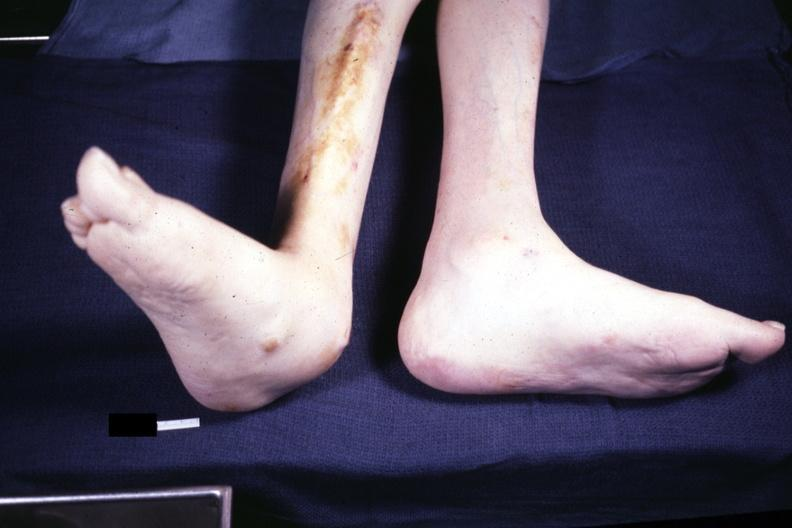what does this image show?
Answer the question using a single word or phrase. Typical deformity with lateral deviation case 31 